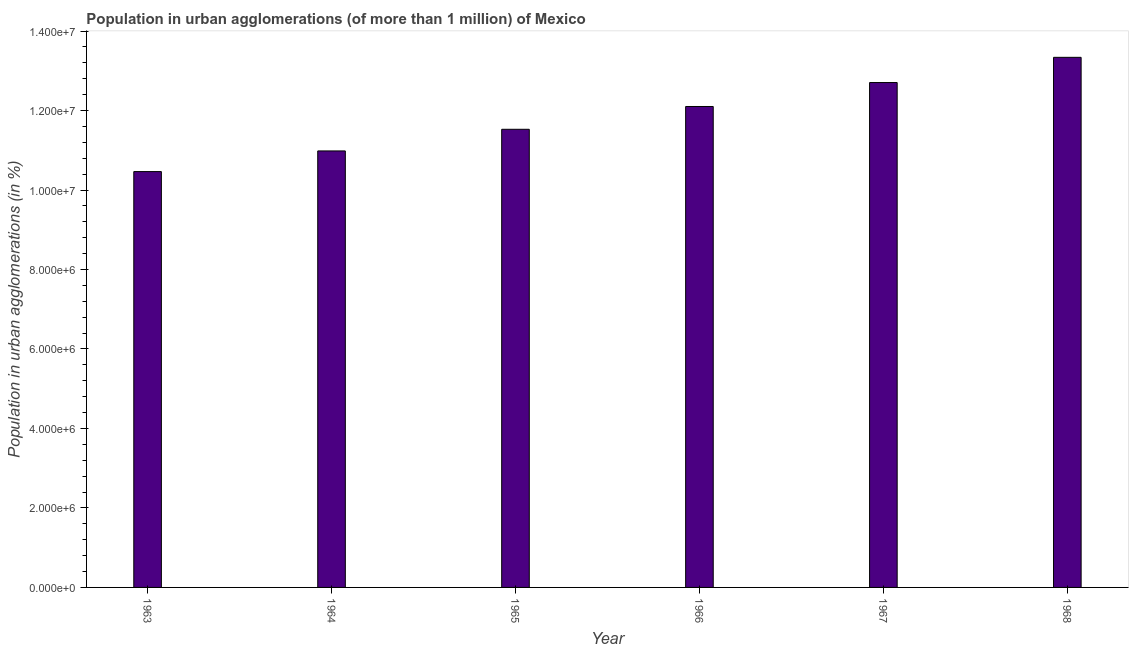What is the title of the graph?
Offer a terse response. Population in urban agglomerations (of more than 1 million) of Mexico. What is the label or title of the Y-axis?
Make the answer very short. Population in urban agglomerations (in %). What is the population in urban agglomerations in 1965?
Give a very brief answer. 1.15e+07. Across all years, what is the maximum population in urban agglomerations?
Your response must be concise. 1.33e+07. Across all years, what is the minimum population in urban agglomerations?
Offer a terse response. 1.05e+07. In which year was the population in urban agglomerations maximum?
Ensure brevity in your answer.  1968. In which year was the population in urban agglomerations minimum?
Give a very brief answer. 1963. What is the sum of the population in urban agglomerations?
Provide a succinct answer. 7.11e+07. What is the difference between the population in urban agglomerations in 1963 and 1966?
Give a very brief answer. -1.64e+06. What is the average population in urban agglomerations per year?
Provide a short and direct response. 1.19e+07. What is the median population in urban agglomerations?
Give a very brief answer. 1.18e+07. What is the ratio of the population in urban agglomerations in 1963 to that in 1968?
Offer a terse response. 0.78. Is the population in urban agglomerations in 1964 less than that in 1968?
Offer a very short reply. Yes. Is the difference between the population in urban agglomerations in 1965 and 1967 greater than the difference between any two years?
Keep it short and to the point. No. What is the difference between the highest and the second highest population in urban agglomerations?
Offer a very short reply. 6.35e+05. Is the sum of the population in urban agglomerations in 1963 and 1965 greater than the maximum population in urban agglomerations across all years?
Your answer should be compact. Yes. What is the difference between the highest and the lowest population in urban agglomerations?
Make the answer very short. 2.88e+06. In how many years, is the population in urban agglomerations greater than the average population in urban agglomerations taken over all years?
Keep it short and to the point. 3. How many bars are there?
Your response must be concise. 6. What is the difference between two consecutive major ticks on the Y-axis?
Your response must be concise. 2.00e+06. Are the values on the major ticks of Y-axis written in scientific E-notation?
Give a very brief answer. Yes. What is the Population in urban agglomerations (in %) of 1963?
Offer a very short reply. 1.05e+07. What is the Population in urban agglomerations (in %) of 1964?
Provide a short and direct response. 1.10e+07. What is the Population in urban agglomerations (in %) in 1965?
Give a very brief answer. 1.15e+07. What is the Population in urban agglomerations (in %) of 1966?
Ensure brevity in your answer.  1.21e+07. What is the Population in urban agglomerations (in %) of 1967?
Make the answer very short. 1.27e+07. What is the Population in urban agglomerations (in %) in 1968?
Your answer should be compact. 1.33e+07. What is the difference between the Population in urban agglomerations (in %) in 1963 and 1964?
Ensure brevity in your answer.  -5.20e+05. What is the difference between the Population in urban agglomerations (in %) in 1963 and 1965?
Your answer should be very brief. -1.06e+06. What is the difference between the Population in urban agglomerations (in %) in 1963 and 1966?
Keep it short and to the point. -1.64e+06. What is the difference between the Population in urban agglomerations (in %) in 1963 and 1967?
Provide a succinct answer. -2.24e+06. What is the difference between the Population in urban agglomerations (in %) in 1963 and 1968?
Make the answer very short. -2.88e+06. What is the difference between the Population in urban agglomerations (in %) in 1964 and 1965?
Your answer should be very brief. -5.45e+05. What is the difference between the Population in urban agglomerations (in %) in 1964 and 1966?
Ensure brevity in your answer.  -1.12e+06. What is the difference between the Population in urban agglomerations (in %) in 1964 and 1967?
Offer a very short reply. -1.72e+06. What is the difference between the Population in urban agglomerations (in %) in 1964 and 1968?
Your answer should be compact. -2.36e+06. What is the difference between the Population in urban agglomerations (in %) in 1965 and 1966?
Offer a terse response. -5.73e+05. What is the difference between the Population in urban agglomerations (in %) in 1965 and 1967?
Your response must be concise. -1.18e+06. What is the difference between the Population in urban agglomerations (in %) in 1965 and 1968?
Ensure brevity in your answer.  -1.81e+06. What is the difference between the Population in urban agglomerations (in %) in 1966 and 1967?
Keep it short and to the point. -6.03e+05. What is the difference between the Population in urban agglomerations (in %) in 1966 and 1968?
Provide a short and direct response. -1.24e+06. What is the difference between the Population in urban agglomerations (in %) in 1967 and 1968?
Provide a succinct answer. -6.35e+05. What is the ratio of the Population in urban agglomerations (in %) in 1963 to that in 1964?
Keep it short and to the point. 0.95. What is the ratio of the Population in urban agglomerations (in %) in 1963 to that in 1965?
Give a very brief answer. 0.91. What is the ratio of the Population in urban agglomerations (in %) in 1963 to that in 1966?
Provide a succinct answer. 0.86. What is the ratio of the Population in urban agglomerations (in %) in 1963 to that in 1967?
Your answer should be very brief. 0.82. What is the ratio of the Population in urban agglomerations (in %) in 1963 to that in 1968?
Keep it short and to the point. 0.78. What is the ratio of the Population in urban agglomerations (in %) in 1964 to that in 1965?
Keep it short and to the point. 0.95. What is the ratio of the Population in urban agglomerations (in %) in 1964 to that in 1966?
Offer a very short reply. 0.91. What is the ratio of the Population in urban agglomerations (in %) in 1964 to that in 1967?
Your answer should be very brief. 0.86. What is the ratio of the Population in urban agglomerations (in %) in 1964 to that in 1968?
Offer a terse response. 0.82. What is the ratio of the Population in urban agglomerations (in %) in 1965 to that in 1966?
Offer a very short reply. 0.95. What is the ratio of the Population in urban agglomerations (in %) in 1965 to that in 1967?
Give a very brief answer. 0.91. What is the ratio of the Population in urban agglomerations (in %) in 1965 to that in 1968?
Your answer should be very brief. 0.86. What is the ratio of the Population in urban agglomerations (in %) in 1966 to that in 1967?
Offer a very short reply. 0.95. What is the ratio of the Population in urban agglomerations (in %) in 1966 to that in 1968?
Offer a very short reply. 0.91. What is the ratio of the Population in urban agglomerations (in %) in 1967 to that in 1968?
Offer a terse response. 0.95. 